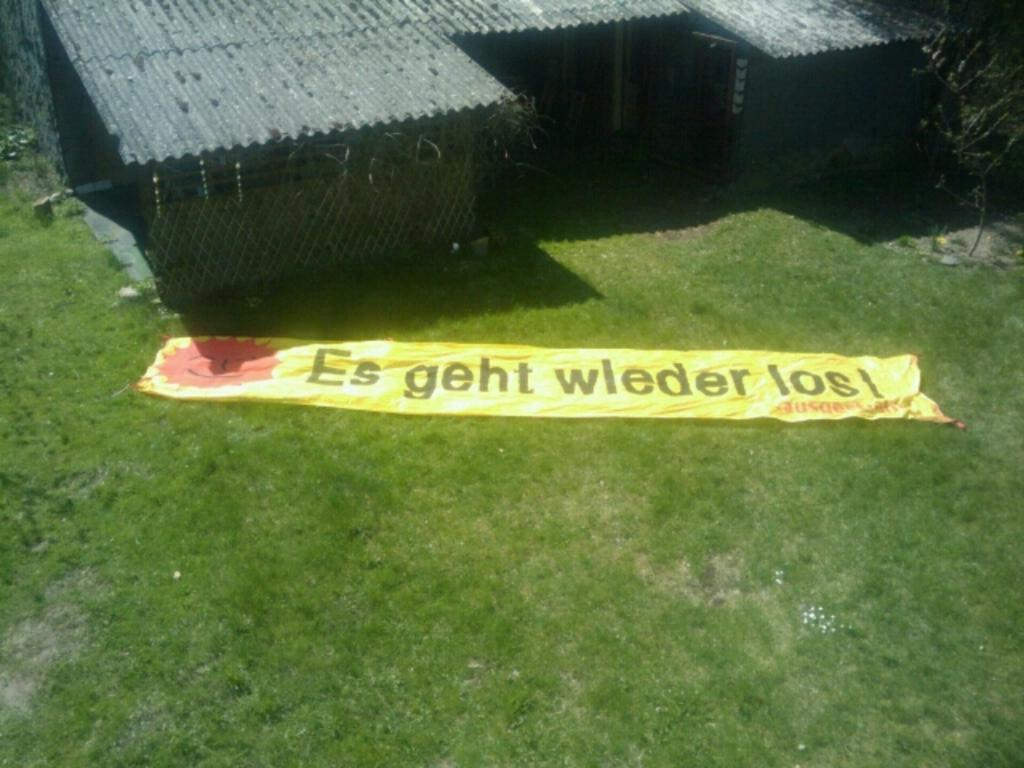What is placed on the grass in the image? There is a banner on the grass. What type of structure can be seen in the image? There is a shed in the image. What type of vegetation is present in the image? There is a plant in the image. What is the volume of the hand in the image? There is no hand present in the image, so it is not possible to determine its volume. 